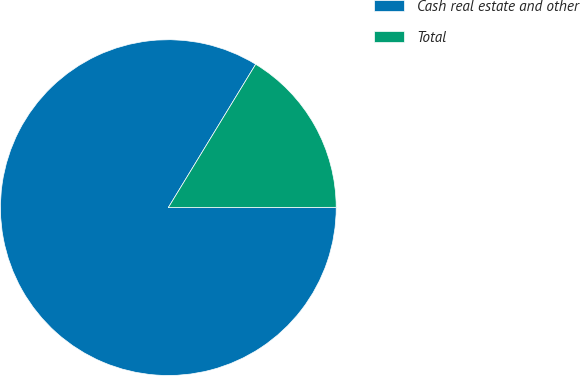Convert chart to OTSL. <chart><loc_0><loc_0><loc_500><loc_500><pie_chart><fcel>Cash real estate and other<fcel>Total<nl><fcel>83.74%<fcel>16.26%<nl></chart> 